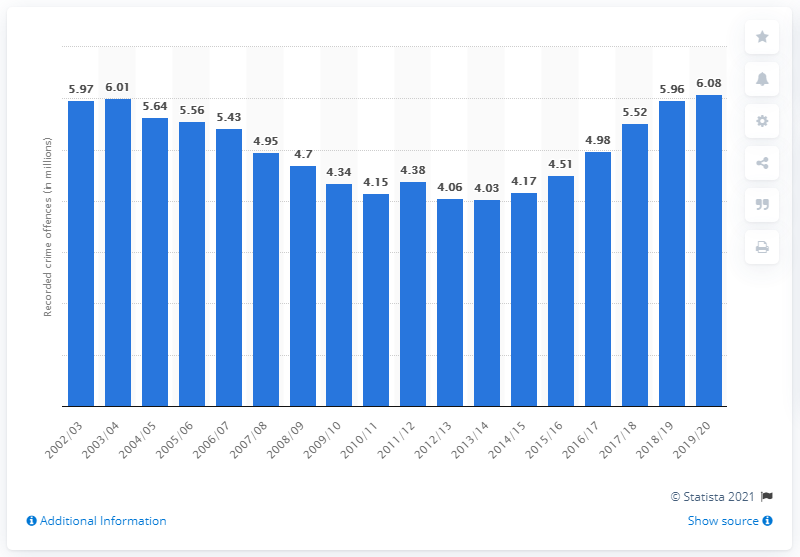Specify some key components in this picture. In the 2019/2020 fiscal year, there were 5.97 crimes reported in England and Wales. In 2013/2014, the number of crimes in England and Wales was 4.03. 